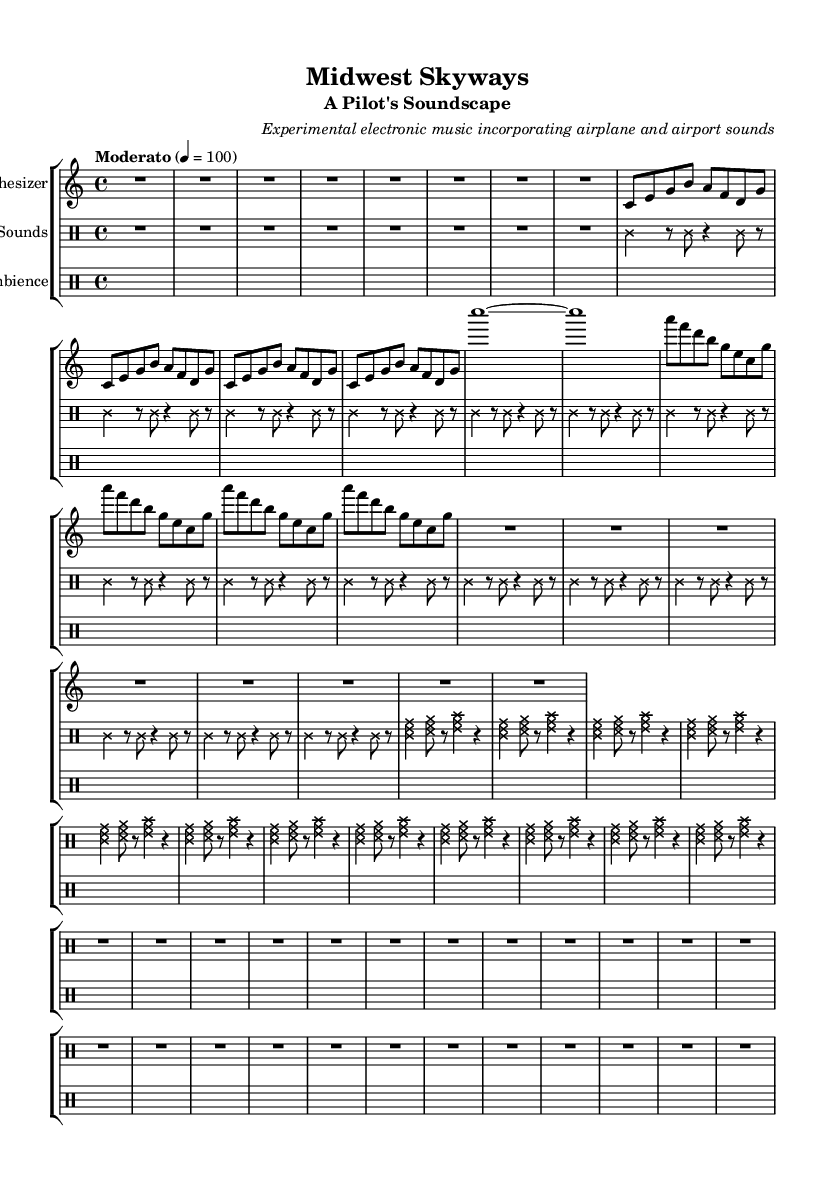What is the time signature of this music? The time signature is indicated at the beginning of the music. In this case, it is written as "4/4," which indicates that there are four beats in each measure and a quarter note gets one beat.
Answer: 4/4 What is the tempo marking for the piece? The tempo marking is found at the beginning of the score. It states "Moderato," and is further defined with a metronome marking of 100 beats per minute, indicating a moderate pace.
Answer: Moderato How many measures are included in the synth melody section? To determine the number of measures, we can count the segments between the bar lines in the synth melody part. Each repeat has a clear structure, and the total is found by counting the measures per repeat or by counting individual measures directly. There are 12 measures in total.
Answer: 12 What is the style of the note heads used in the airplane sounds? The note heads' style is modified for artistic expression. The airplane sounds part uses a 'cross' style for the notes, which visually distinguishes this section from others. This can be identified by looking for the overridden note head style in that staff.
Answer: cross How does the structure of the airport ambience differ from the other sections? The airport ambience section uses only rests and shows no actual pitches being played, represented by sustained silence. This punctuation is significant in creating a different sound texture compared to the active melody and sounds of the synth and airplane sections, enhancing the experimental nature of the music.
Answer: Silence 